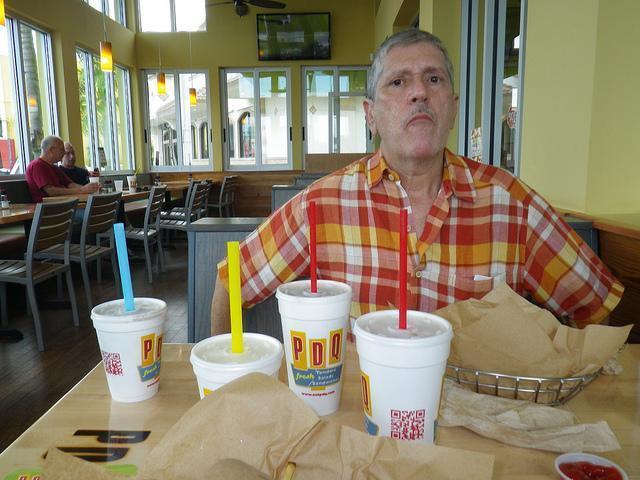How many people are there?
Give a very brief answer. 3. How many chairs are there?
Give a very brief answer. 2. How many cups can be seen?
Give a very brief answer. 4. 